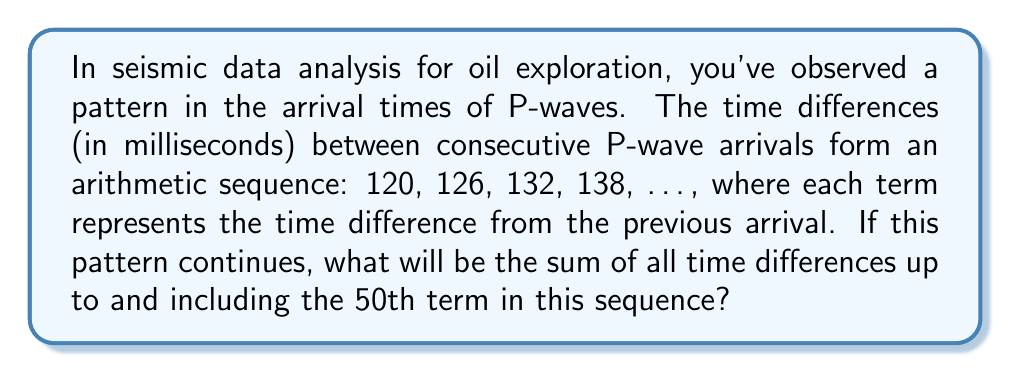Show me your answer to this math problem. Let's approach this step-by-step using concepts from number theory:

1) First, we identify the arithmetic sequence:
   - First term (a₁) = 120 ms
   - Common difference (d) = 6 ms

2) The nth term of an arithmetic sequence is given by:
   $a_n = a_1 + (n-1)d$

3) We need to find the 50th term:
   $a_{50} = 120 + (50-1)6 = 120 + 294 = 414$ ms

4) Now, we need to find the sum of all terms up to the 50th term. For arithmetic sequences, we can use the formula:
   $S_n = \frac{n}{2}(a_1 + a_n)$
   Where $S_n$ is the sum of n terms, $a_1$ is the first term, and $a_n$ is the nth term.

5) Substituting our values:
   $S_{50} = \frac{50}{2}(120 + 414)$
   $S_{50} = 25(534)$
   $S_{50} = 13,350$ ms

Therefore, the sum of all time differences up to and including the 50th term is 13,350 milliseconds.
Answer: 13,350 ms 